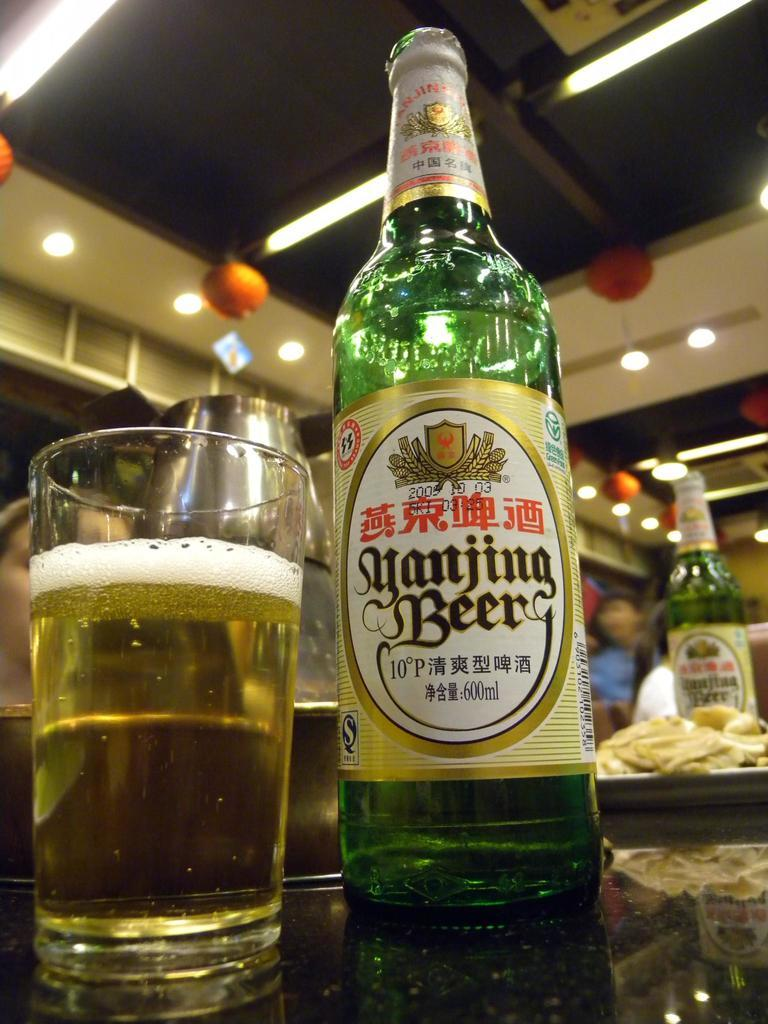<image>
Give a short and clear explanation of the subsequent image. Bottle of Yanjing Beer poured in a cup. 